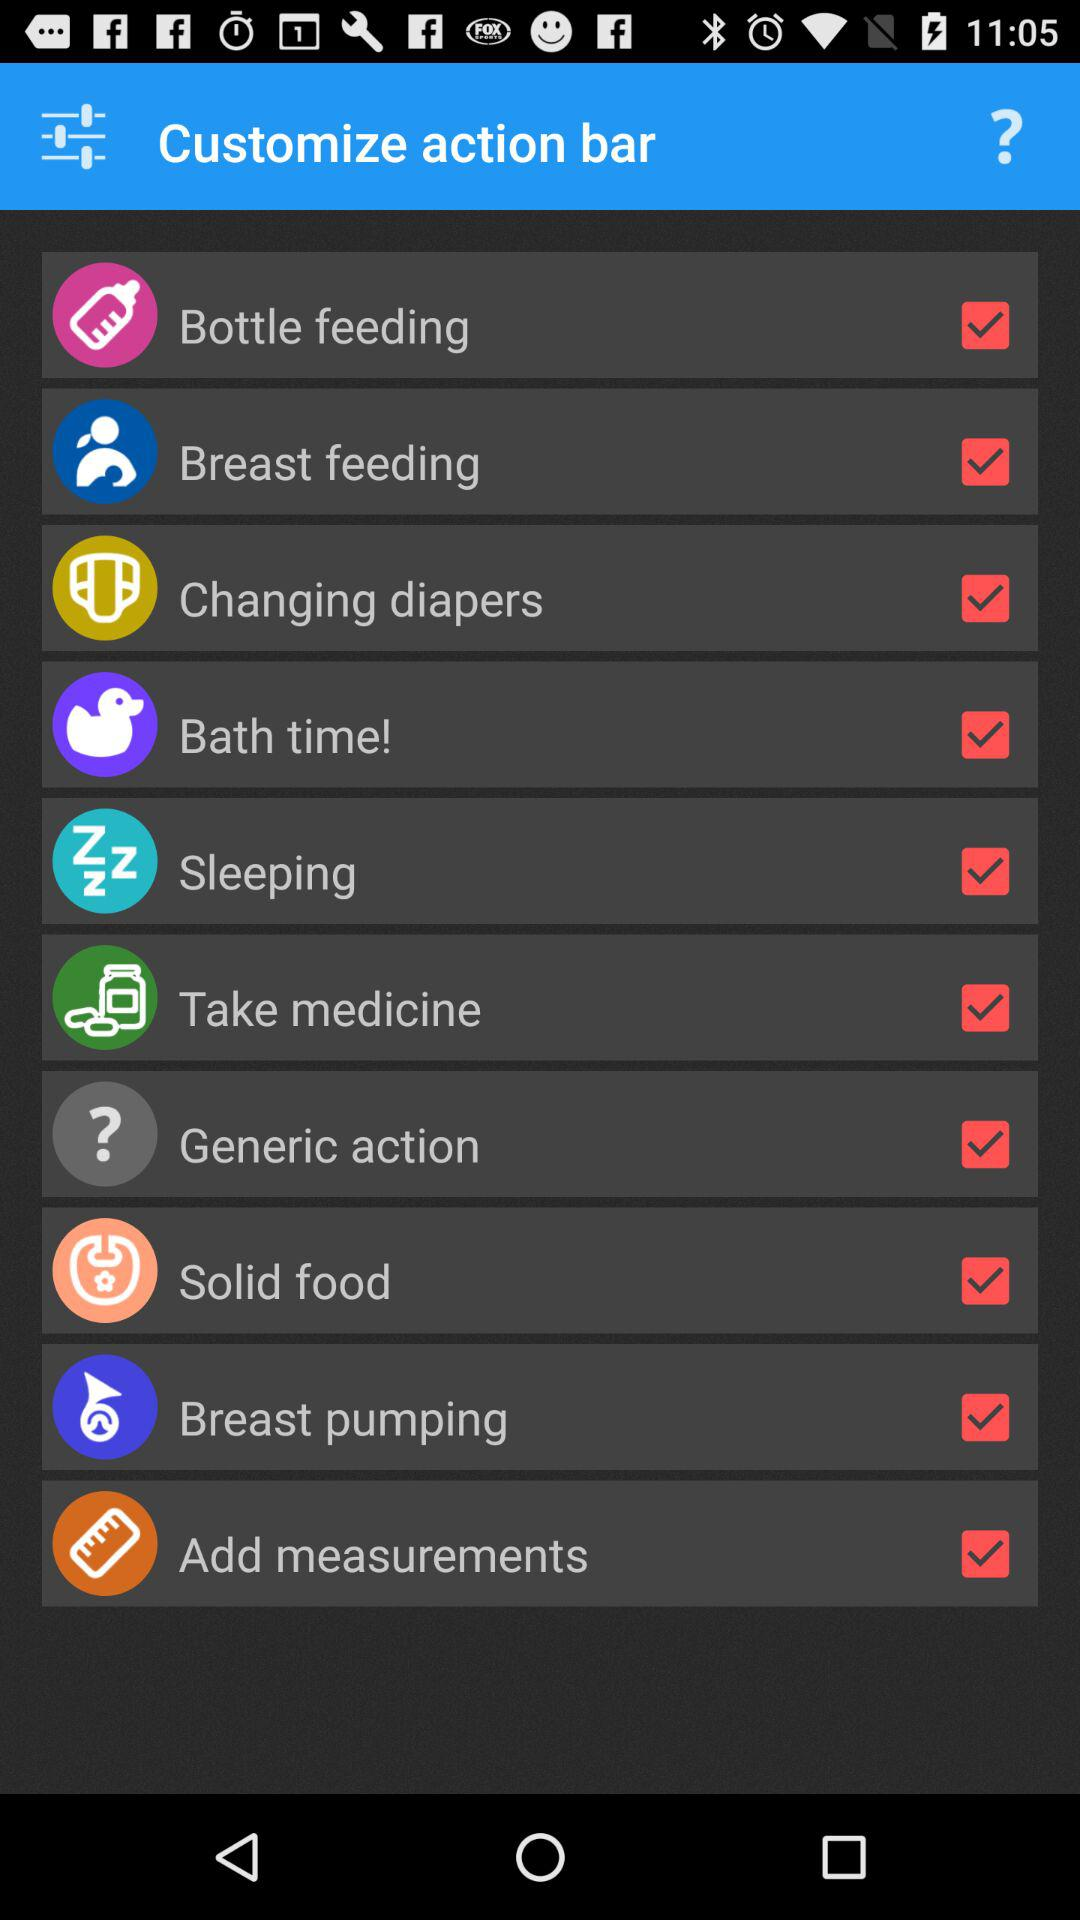How old is the baby?
When the provided information is insufficient, respond with <no answer>. <no answer> 